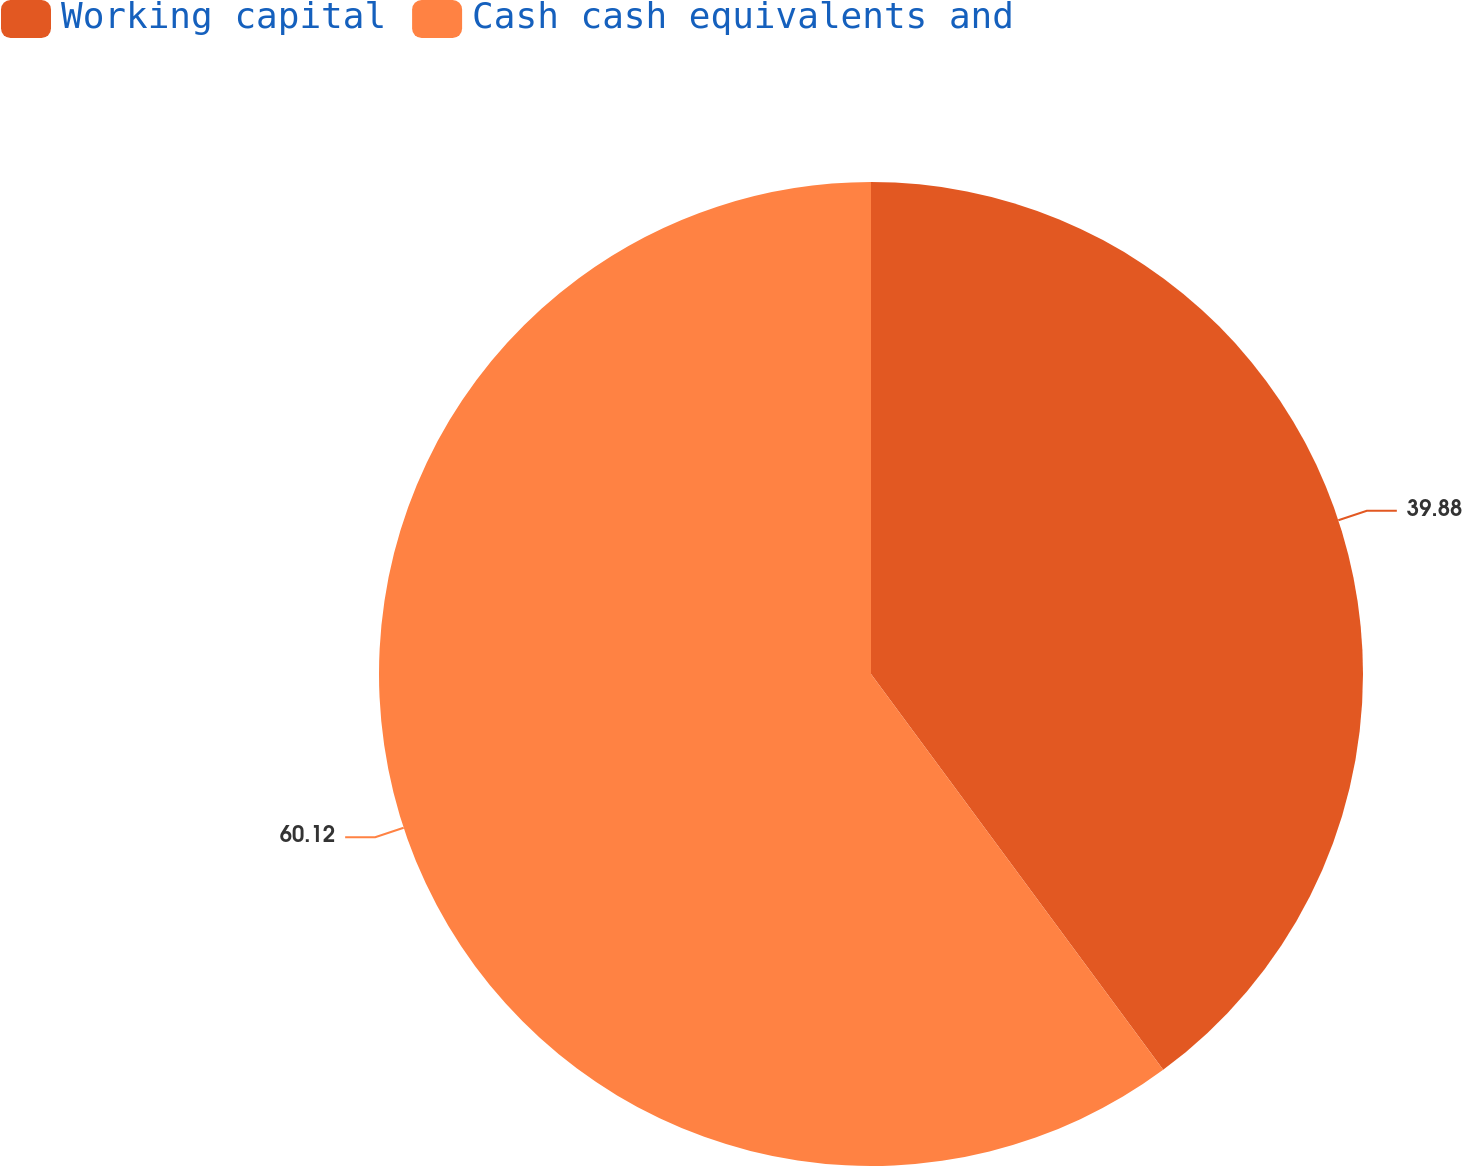Convert chart. <chart><loc_0><loc_0><loc_500><loc_500><pie_chart><fcel>Working capital<fcel>Cash cash equivalents and<nl><fcel>39.88%<fcel>60.12%<nl></chart> 